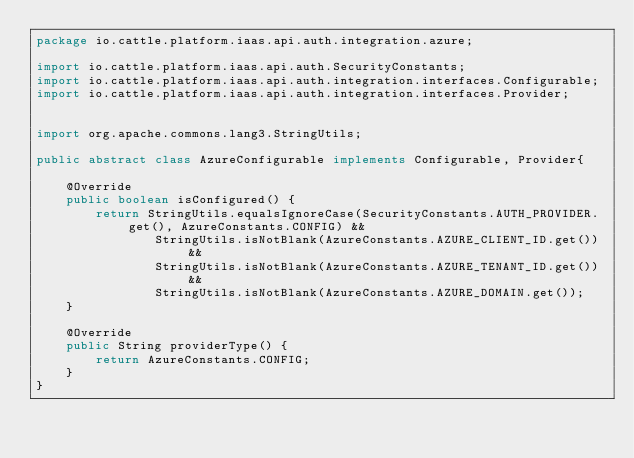Convert code to text. <code><loc_0><loc_0><loc_500><loc_500><_Java_>package io.cattle.platform.iaas.api.auth.integration.azure;

import io.cattle.platform.iaas.api.auth.SecurityConstants;
import io.cattle.platform.iaas.api.auth.integration.interfaces.Configurable;
import io.cattle.platform.iaas.api.auth.integration.interfaces.Provider;


import org.apache.commons.lang3.StringUtils;

public abstract class AzureConfigurable implements Configurable, Provider{

    @Override
    public boolean isConfigured() {
        return StringUtils.equalsIgnoreCase(SecurityConstants.AUTH_PROVIDER.get(), AzureConstants.CONFIG) &&
                StringUtils.isNotBlank(AzureConstants.AZURE_CLIENT_ID.get()) &&
                StringUtils.isNotBlank(AzureConstants.AZURE_TENANT_ID.get()) && 
                StringUtils.isNotBlank(AzureConstants.AZURE_DOMAIN.get());
    }

    @Override
    public String providerType() {
        return AzureConstants.CONFIG;
    }
}
</code> 